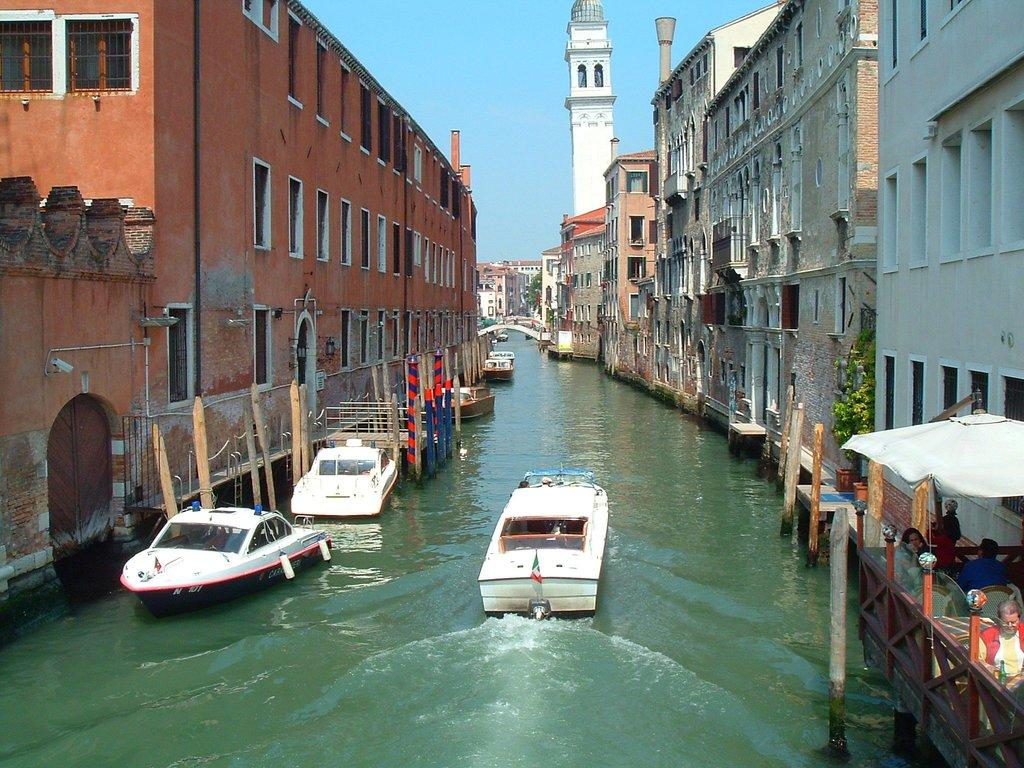What type of structures can be seen in the image? There are buildings in the image. What other items can be found in the image? There are objects, windows, plants, wooden logs, and boats on the water surface in the image. Can you describe the natural elements in the image? There are plants and wooden logs in the image. What is visible in the sky in the image? The sky is visible in the image. What are the people in the image doing? There are people sitting on chairs in the image. What type of linen is draped over the boats in the image? There is no linen draped over the boats in the image; the boats are on the water surface without any coverings. How many spiders can be seen crawling on the windows in the image? There are no spiders visible in the image, and therefore no such activity can be observed. 